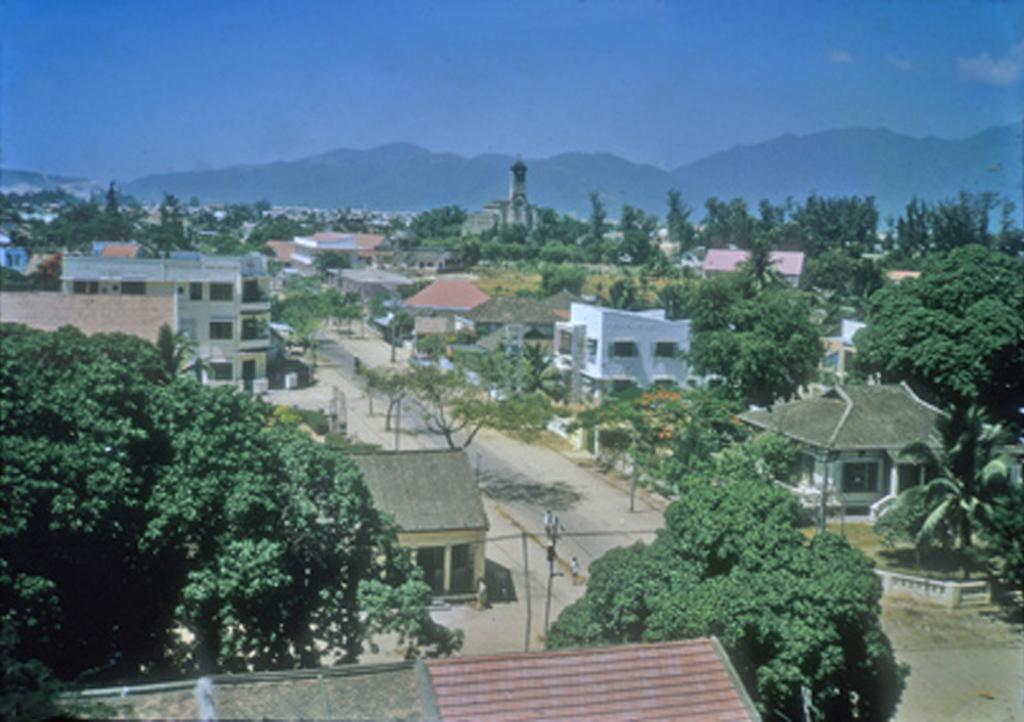What type of structures can be seen in the image? There are buildings, a tower, and poles in the image. What type of natural elements are present in the image? There are trees and a hill in the image. What type of man-made infrastructure can be seen in the image? There is a road in the image. What type of people can be seen in the image? There are parsons in the image. What is visible in the sky in the image? The sky is visible, and there are clouds in the image. Can you tell me how many airplanes are flying over the hill in the image? There are no airplanes visible in the image; it only shows buildings, trees, poles, a tower, a road, parsons, a hill, and the sky with clouds. What historical event is taking place in the image? There is no indication of any historical event taking place in the image. 